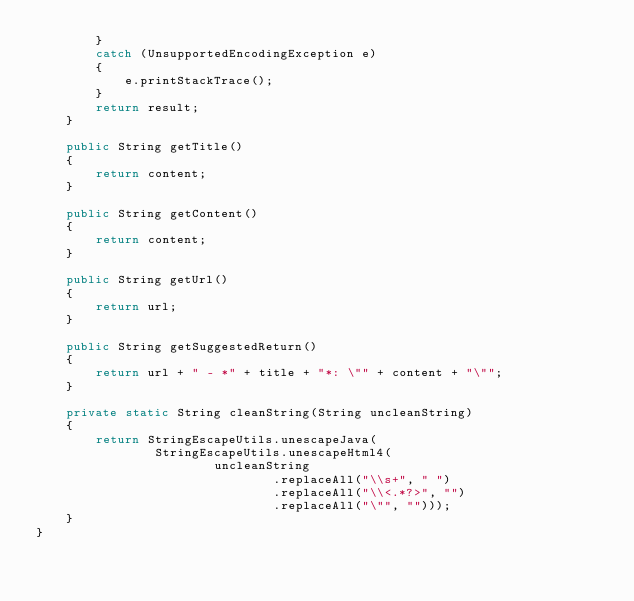Convert code to text. <code><loc_0><loc_0><loc_500><loc_500><_Java_>        }
        catch (UnsupportedEncodingException e)
        {
            e.printStackTrace();
        }
        return result;
    }

    public String getTitle()
    {
        return content;
    }

    public String getContent()
    {
        return content;
    }

    public String getUrl()
    {
        return url;
    }

    public String getSuggestedReturn()
    {
        return url + " - *" + title + "*: \"" + content + "\"";
    }

    private static String cleanString(String uncleanString)
    {
        return StringEscapeUtils.unescapeJava(
                StringEscapeUtils.unescapeHtml4(
                        uncleanString
                                .replaceAll("\\s+", " ")
                                .replaceAll("\\<.*?>", "")
                                .replaceAll("\"", "")));
    }
}
</code> 